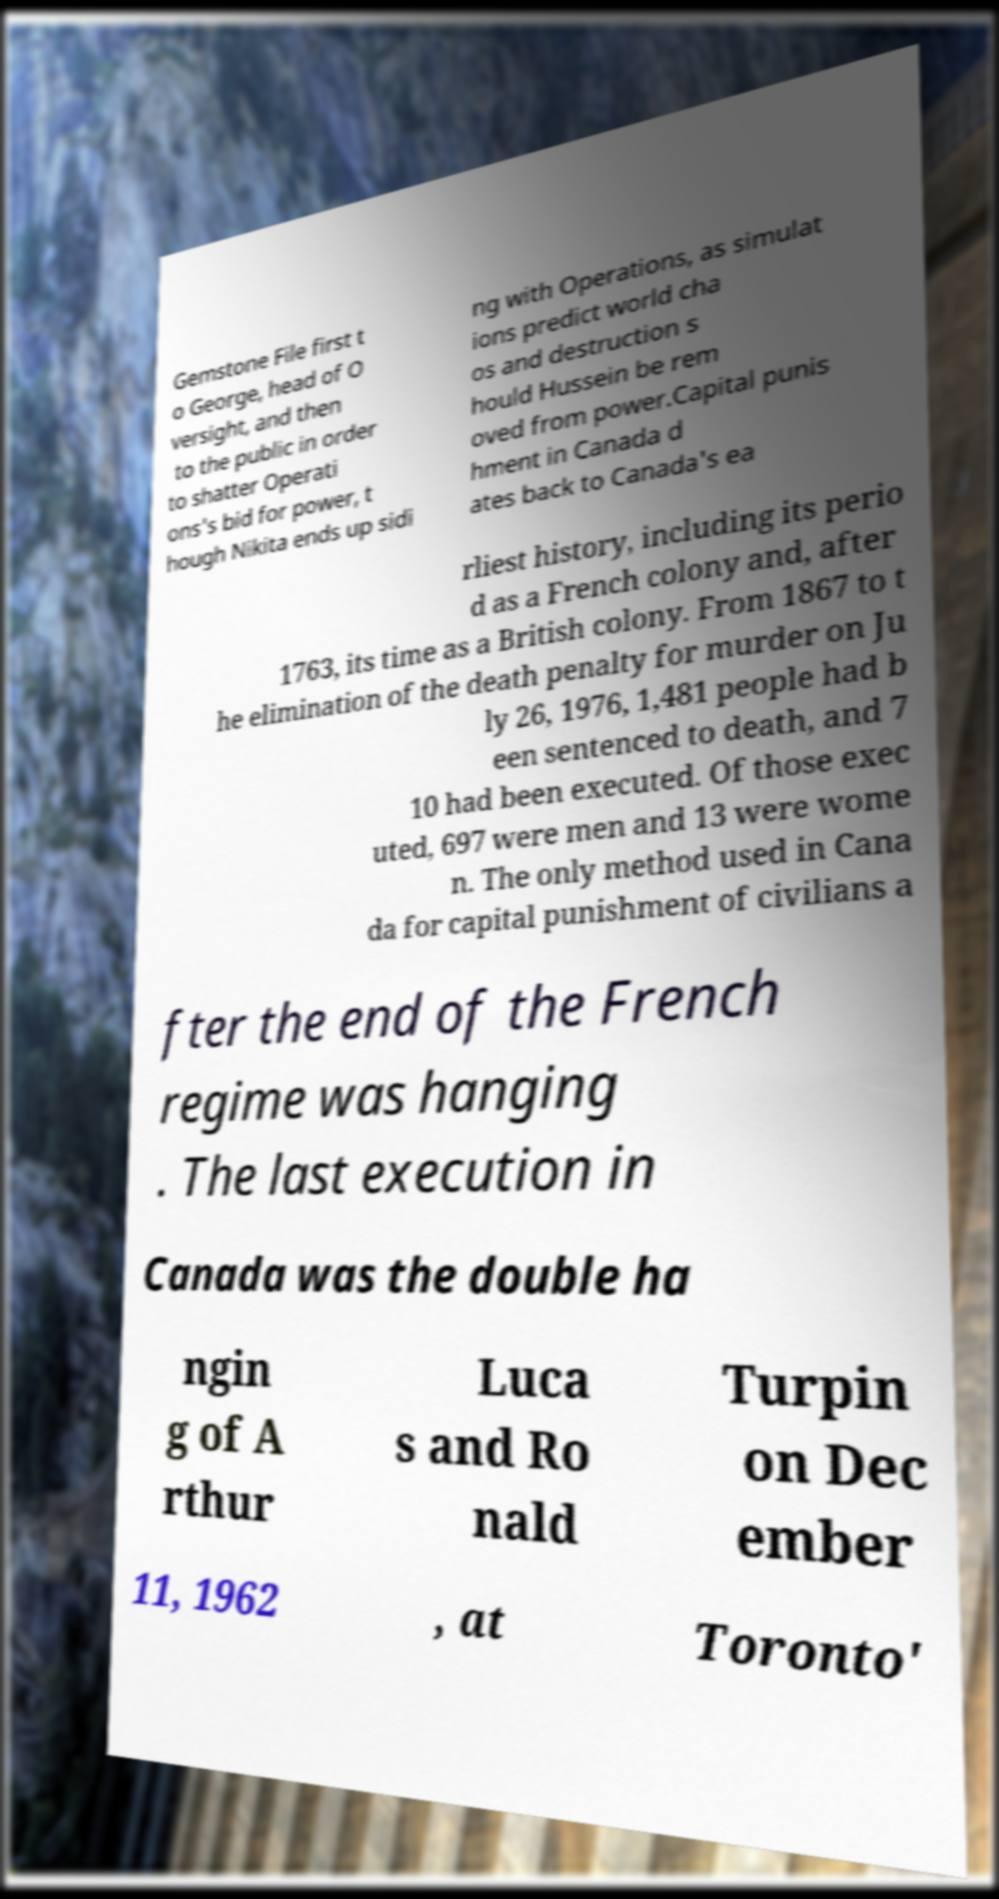For documentation purposes, I need the text within this image transcribed. Could you provide that? Gemstone File first t o George, head of O versight, and then to the public in order to shatter Operati ons's bid for power, t hough Nikita ends up sidi ng with Operations, as simulat ions predict world cha os and destruction s hould Hussein be rem oved from power.Capital punis hment in Canada d ates back to Canada's ea rliest history, including its perio d as a French colony and, after 1763, its time as a British colony. From 1867 to t he elimination of the death penalty for murder on Ju ly 26, 1976, 1,481 people had b een sentenced to death, and 7 10 had been executed. Of those exec uted, 697 were men and 13 were wome n. The only method used in Cana da for capital punishment of civilians a fter the end of the French regime was hanging . The last execution in Canada was the double ha ngin g of A rthur Luca s and Ro nald Turpin on Dec ember 11, 1962 , at Toronto' 